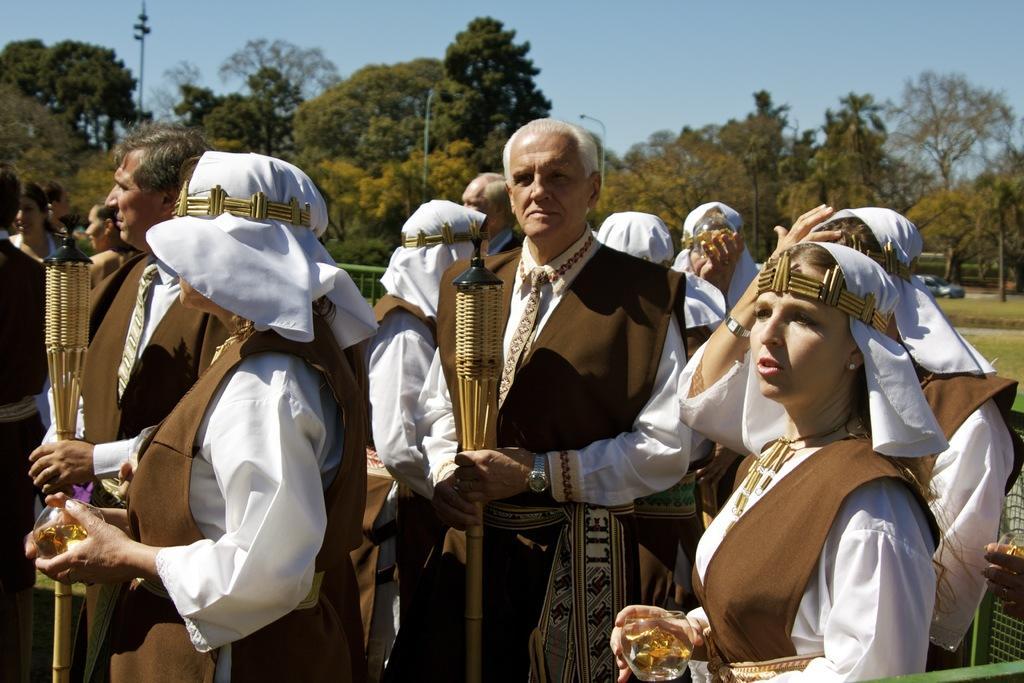In one or two sentences, can you explain what this image depicts? In this picture there are people standing and holding objects and we can see mesh. In the background of the image we can see trees, car, poles and sky. 